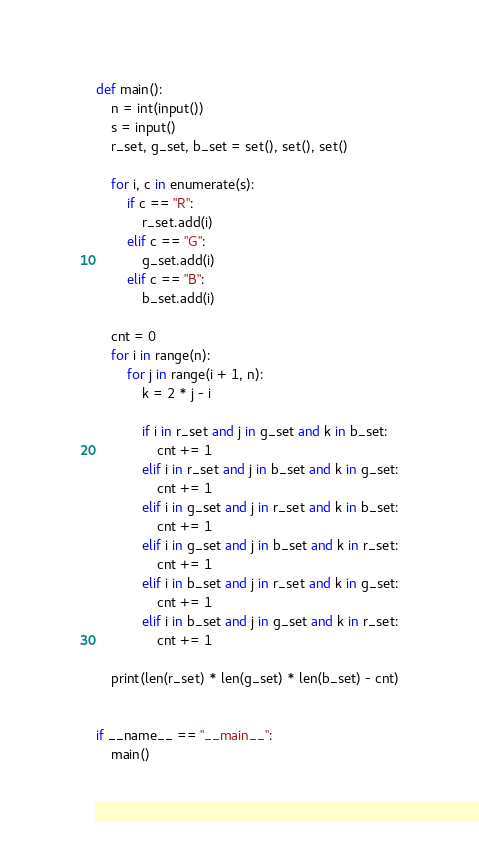Convert code to text. <code><loc_0><loc_0><loc_500><loc_500><_Python_>def main():
    n = int(input())
    s = input()
    r_set, g_set, b_set = set(), set(), set()

    for i, c in enumerate(s):
        if c == "R":
            r_set.add(i)
        elif c == "G":
            g_set.add(i)
        elif c == "B":
            b_set.add(i)

    cnt = 0
    for i in range(n):
        for j in range(i + 1, n):
            k = 2 * j - i

            if i in r_set and j in g_set and k in b_set:
                cnt += 1
            elif i in r_set and j in b_set and k in g_set:
                cnt += 1
            elif i in g_set and j in r_set and k in b_set:
                cnt += 1
            elif i in g_set and j in b_set and k in r_set:
                cnt += 1
            elif i in b_set and j in r_set and k in g_set:
                cnt += 1
            elif i in b_set and j in g_set and k in r_set:
                cnt += 1

    print(len(r_set) * len(g_set) * len(b_set) - cnt)


if __name__ == "__main__":
    main()
</code> 